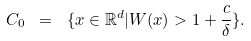<formula> <loc_0><loc_0><loc_500><loc_500>C _ { 0 } \ = \ \{ x \in \mathbb { R } ^ { d } | W ( x ) > 1 + \frac { c } { \delta } \} .</formula> 